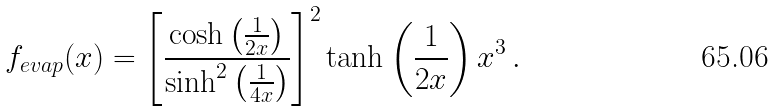<formula> <loc_0><loc_0><loc_500><loc_500>f _ { e v a p } ( x ) = \left [ \frac { \cosh \left ( \frac { 1 } { 2 x } \right ) } { \sinh ^ { 2 } \left ( \frac { 1 } { 4 x } \right ) } \right ] ^ { 2 } \tanh \left ( \frac { 1 } { 2 x } \right ) x ^ { 3 } \, .</formula> 